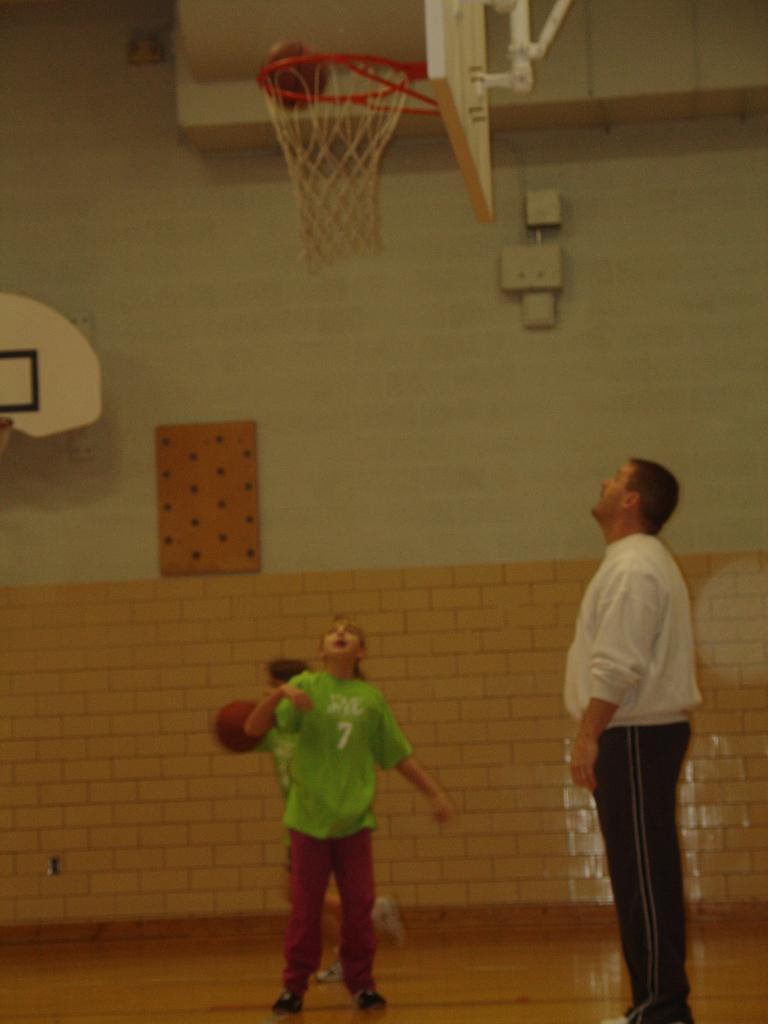Could you give a brief overview of what you see in this image? In this image we can see two persons playing basketball on a court. There is a person watching at the ball. Behind the persons we can see a wall. At the top we can see the basketball net with backboard and ball. On the left side, we can see a basketball backboard. 